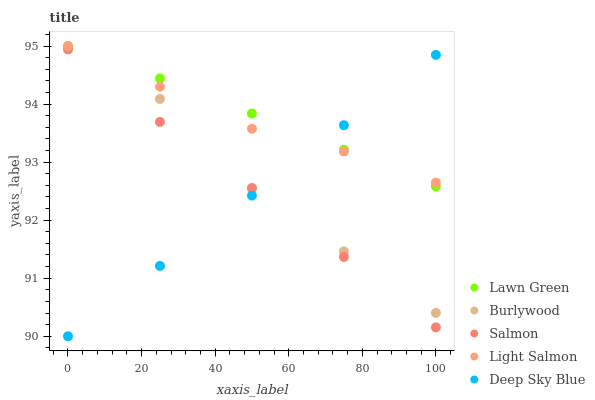Does Deep Sky Blue have the minimum area under the curve?
Answer yes or no. Yes. Does Lawn Green have the maximum area under the curve?
Answer yes or no. Yes. Does Light Salmon have the minimum area under the curve?
Answer yes or no. No. Does Light Salmon have the maximum area under the curve?
Answer yes or no. No. Is Deep Sky Blue the smoothest?
Answer yes or no. Yes. Is Burlywood the roughest?
Answer yes or no. Yes. Is Lawn Green the smoothest?
Answer yes or no. No. Is Lawn Green the roughest?
Answer yes or no. No. Does Deep Sky Blue have the lowest value?
Answer yes or no. Yes. Does Lawn Green have the lowest value?
Answer yes or no. No. Does Light Salmon have the highest value?
Answer yes or no. Yes. Does Salmon have the highest value?
Answer yes or no. No. Is Salmon less than Light Salmon?
Answer yes or no. Yes. Is Lawn Green greater than Burlywood?
Answer yes or no. Yes. Does Deep Sky Blue intersect Light Salmon?
Answer yes or no. Yes. Is Deep Sky Blue less than Light Salmon?
Answer yes or no. No. Is Deep Sky Blue greater than Light Salmon?
Answer yes or no. No. Does Salmon intersect Light Salmon?
Answer yes or no. No. 